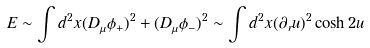<formula> <loc_0><loc_0><loc_500><loc_500>E \sim \int d ^ { 2 } x ( D _ { \mu } \phi _ { + } ) ^ { 2 } + ( D _ { \mu } \phi _ { - } ) ^ { 2 } \sim \int d ^ { 2 } x ( \partial _ { r } u ) ^ { 2 } \cosh 2 u</formula> 